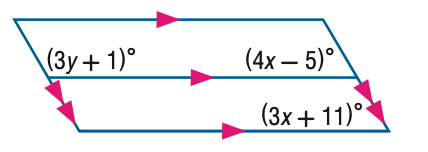Answer the mathemtical geometry problem and directly provide the correct option letter.
Question: Find y in the figure.
Choices: A: 20 B: 30 C: 40 D: 50 C 